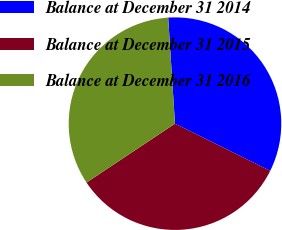<chart> <loc_0><loc_0><loc_500><loc_500><pie_chart><fcel>Balance at December 31 2014<fcel>Balance at December 31 2015<fcel>Balance at December 31 2016<nl><fcel>33.33%<fcel>33.33%<fcel>33.33%<nl></chart> 